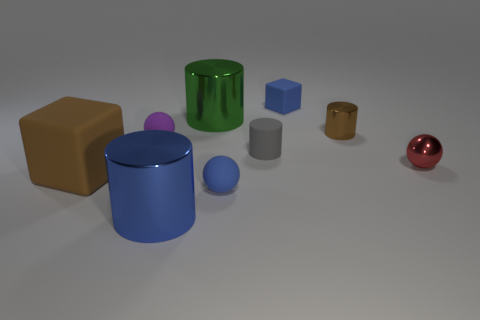What material is the small blue thing that is the same shape as the tiny red thing?
Your answer should be compact. Rubber. There is a big object that is behind the large blue metallic cylinder and on the right side of the purple sphere; what is its shape?
Keep it short and to the point. Cylinder. There is a small blue rubber thing behind the big brown matte thing; what is its shape?
Keep it short and to the point. Cube. How many tiny balls are both to the right of the tiny gray thing and on the left side of the small metal sphere?
Provide a succinct answer. 0. There is a purple ball; does it have the same size as the metallic thing in front of the red metal ball?
Your answer should be very brief. No. There is a rubber block that is on the right side of the blue rubber object in front of the small rubber ball left of the blue metal object; what is its size?
Keep it short and to the point. Small. What is the size of the ball to the left of the blue ball?
Your answer should be very brief. Small. The brown object that is made of the same material as the green thing is what shape?
Your answer should be compact. Cylinder. Do the block behind the tiny purple sphere and the gray thing have the same material?
Your answer should be very brief. Yes. How many other objects are there of the same material as the blue sphere?
Your answer should be very brief. 4. 